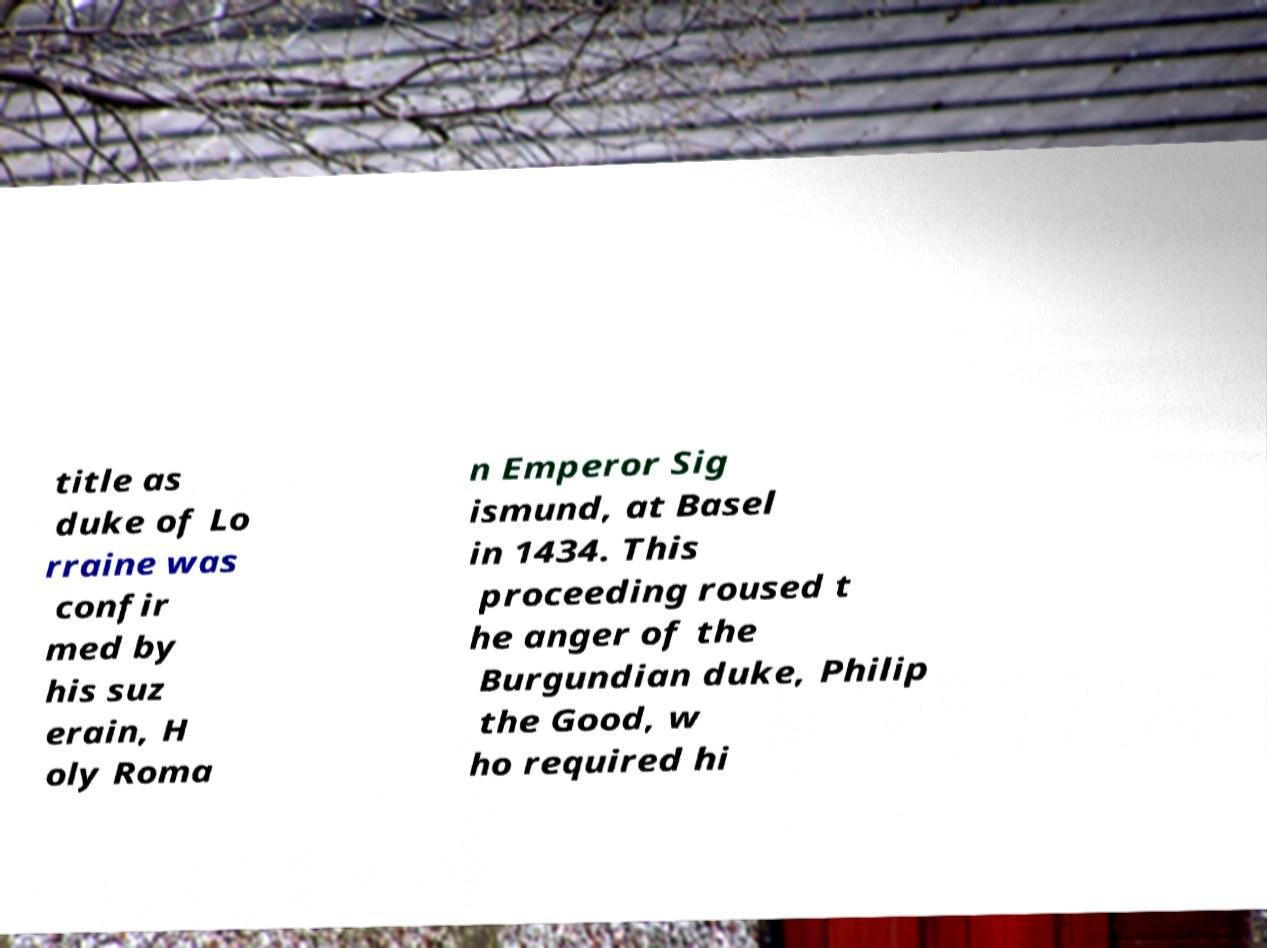For documentation purposes, I need the text within this image transcribed. Could you provide that? title as duke of Lo rraine was confir med by his suz erain, H oly Roma n Emperor Sig ismund, at Basel in 1434. This proceeding roused t he anger of the Burgundian duke, Philip the Good, w ho required hi 